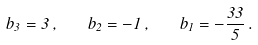Convert formula to latex. <formula><loc_0><loc_0><loc_500><loc_500>b _ { 3 } = 3 \, , \quad b _ { 2 } = - 1 \, , \quad b _ { 1 } = - \frac { 3 3 } { 5 } \, .</formula> 